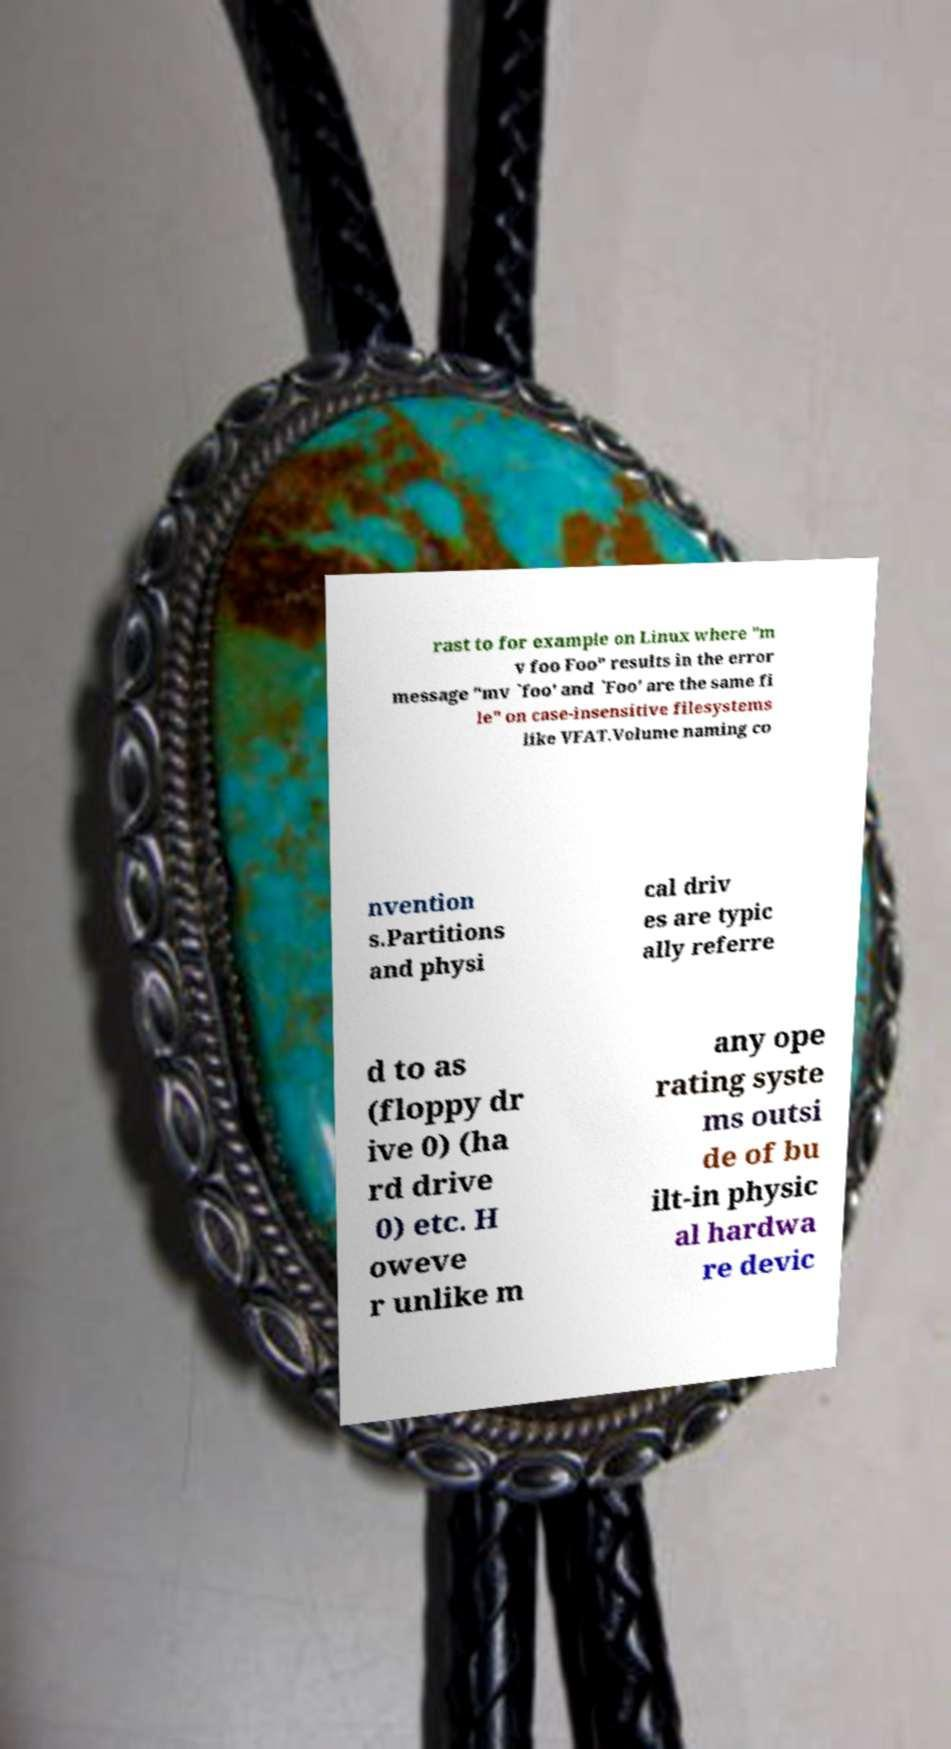For documentation purposes, I need the text within this image transcribed. Could you provide that? rast to for example on Linux where "m v foo Foo" results in the error message "mv `foo' and `Foo' are the same fi le" on case-insensitive filesystems like VFAT.Volume naming co nvention s.Partitions and physi cal driv es are typic ally referre d to as (floppy dr ive 0) (ha rd drive 0) etc. H oweve r unlike m any ope rating syste ms outsi de of bu ilt-in physic al hardwa re devic 